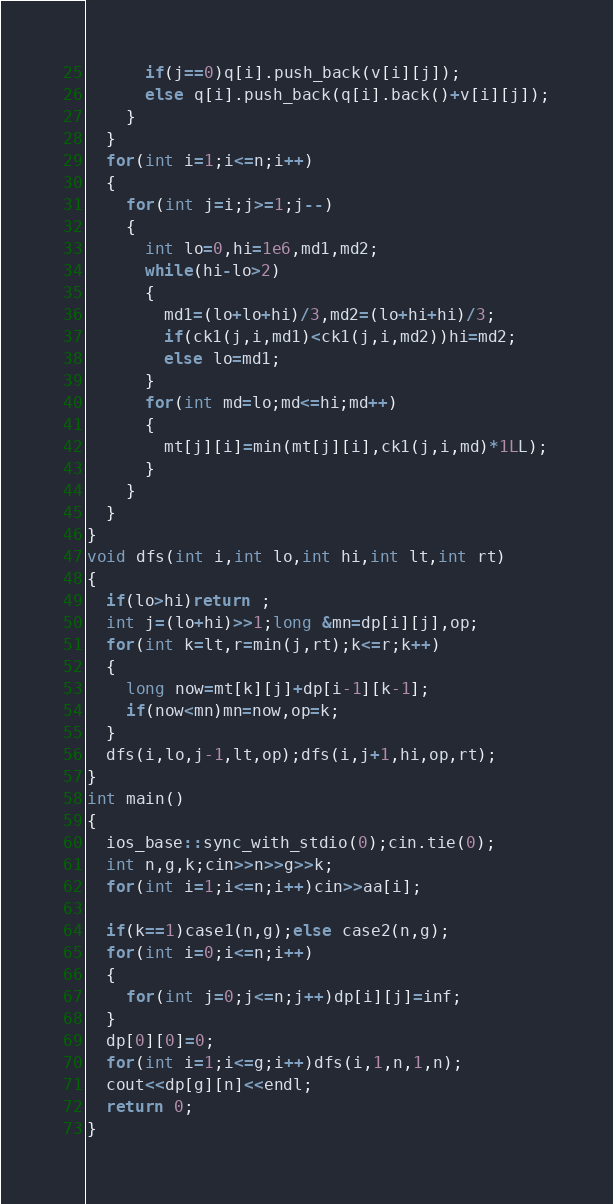Convert code to text. <code><loc_0><loc_0><loc_500><loc_500><_C++_>      if(j==0)q[i].push_back(v[i][j]);
      else q[i].push_back(q[i].back()+v[i][j]);
    }
  }
  for(int i=1;i<=n;i++)
  {
    for(int j=i;j>=1;j--)
    {
      int lo=0,hi=1e6,md1,md2;
      while(hi-lo>2)
      {
        md1=(lo+lo+hi)/3,md2=(lo+hi+hi)/3;
        if(ck1(j,i,md1)<ck1(j,i,md2))hi=md2;
        else lo=md1;
      }
      for(int md=lo;md<=hi;md++)
      {
        mt[j][i]=min(mt[j][i],ck1(j,i,md)*1LL);
      }
    }
  }
} 
void dfs(int i,int lo,int hi,int lt,int rt)
{
  if(lo>hi)return ;
  int j=(lo+hi)>>1;long &mn=dp[i][j],op;
  for(int k=lt,r=min(j,rt);k<=r;k++)
  {
    long now=mt[k][j]+dp[i-1][k-1];
    if(now<mn)mn=now,op=k;
  }
  dfs(i,lo,j-1,lt,op);dfs(i,j+1,hi,op,rt);
}
int main()
{
  ios_base::sync_with_stdio(0);cin.tie(0);
  int n,g,k;cin>>n>>g>>k;
  for(int i=1;i<=n;i++)cin>>aa[i];

  if(k==1)case1(n,g);else case2(n,g);
  for(int i=0;i<=n;i++)
  {
    for(int j=0;j<=n;j++)dp[i][j]=inf;
  }
  dp[0][0]=0;
  for(int i=1;i<=g;i++)dfs(i,1,n,1,n);
  cout<<dp[g][n]<<endl;
  return 0;
}</code> 